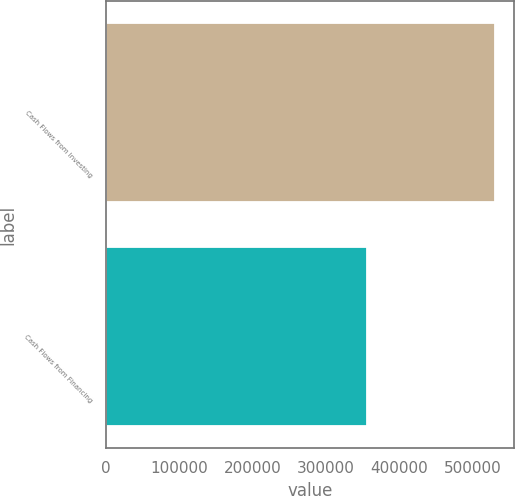Convert chart to OTSL. <chart><loc_0><loc_0><loc_500><loc_500><bar_chart><fcel>Cash Flows from Investing<fcel>Cash Flows from Financing<nl><fcel>530160<fcel>355292<nl></chart> 